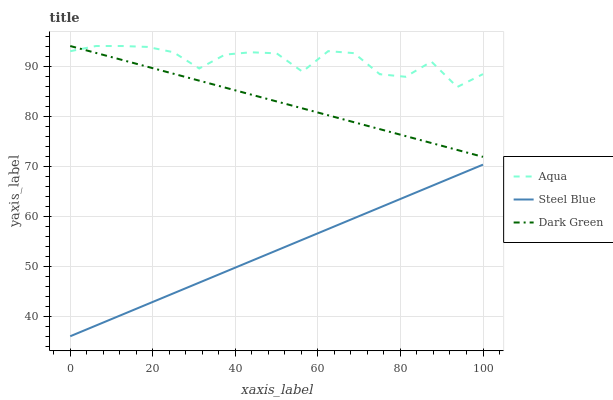Does Steel Blue have the minimum area under the curve?
Answer yes or no. Yes. Does Aqua have the maximum area under the curve?
Answer yes or no. Yes. Does Dark Green have the minimum area under the curve?
Answer yes or no. No. Does Dark Green have the maximum area under the curve?
Answer yes or no. No. Is Steel Blue the smoothest?
Answer yes or no. Yes. Is Aqua the roughest?
Answer yes or no. Yes. Is Dark Green the smoothest?
Answer yes or no. No. Is Dark Green the roughest?
Answer yes or no. No. Does Steel Blue have the lowest value?
Answer yes or no. Yes. Does Dark Green have the lowest value?
Answer yes or no. No. Does Dark Green have the highest value?
Answer yes or no. Yes. Does Steel Blue have the highest value?
Answer yes or no. No. Is Steel Blue less than Aqua?
Answer yes or no. Yes. Is Dark Green greater than Steel Blue?
Answer yes or no. Yes. Does Aqua intersect Dark Green?
Answer yes or no. Yes. Is Aqua less than Dark Green?
Answer yes or no. No. Is Aqua greater than Dark Green?
Answer yes or no. No. Does Steel Blue intersect Aqua?
Answer yes or no. No. 